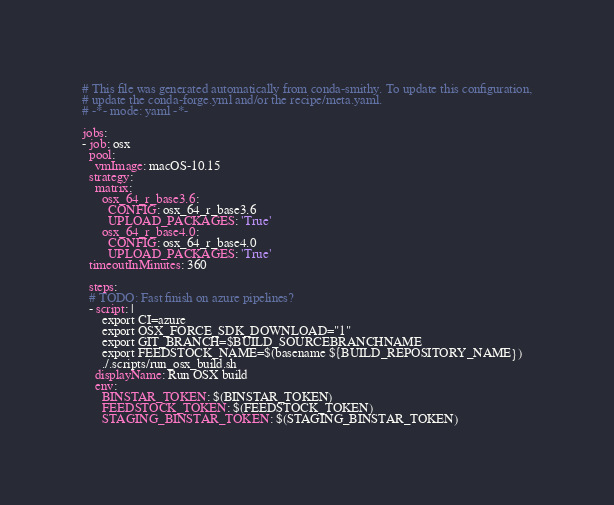Convert code to text. <code><loc_0><loc_0><loc_500><loc_500><_YAML_># This file was generated automatically from conda-smithy. To update this configuration,
# update the conda-forge.yml and/or the recipe/meta.yaml.
# -*- mode: yaml -*-

jobs:
- job: osx
  pool:
    vmImage: macOS-10.15
  strategy:
    matrix:
      osx_64_r_base3.6:
        CONFIG: osx_64_r_base3.6
        UPLOAD_PACKAGES: 'True'
      osx_64_r_base4.0:
        CONFIG: osx_64_r_base4.0
        UPLOAD_PACKAGES: 'True'
  timeoutInMinutes: 360

  steps:
  # TODO: Fast finish on azure pipelines?
  - script: |
      export CI=azure
      export OSX_FORCE_SDK_DOWNLOAD="1"
      export GIT_BRANCH=$BUILD_SOURCEBRANCHNAME
      export FEEDSTOCK_NAME=$(basename ${BUILD_REPOSITORY_NAME})
      ./.scripts/run_osx_build.sh
    displayName: Run OSX build
    env:
      BINSTAR_TOKEN: $(BINSTAR_TOKEN)
      FEEDSTOCK_TOKEN: $(FEEDSTOCK_TOKEN)
      STAGING_BINSTAR_TOKEN: $(STAGING_BINSTAR_TOKEN)</code> 